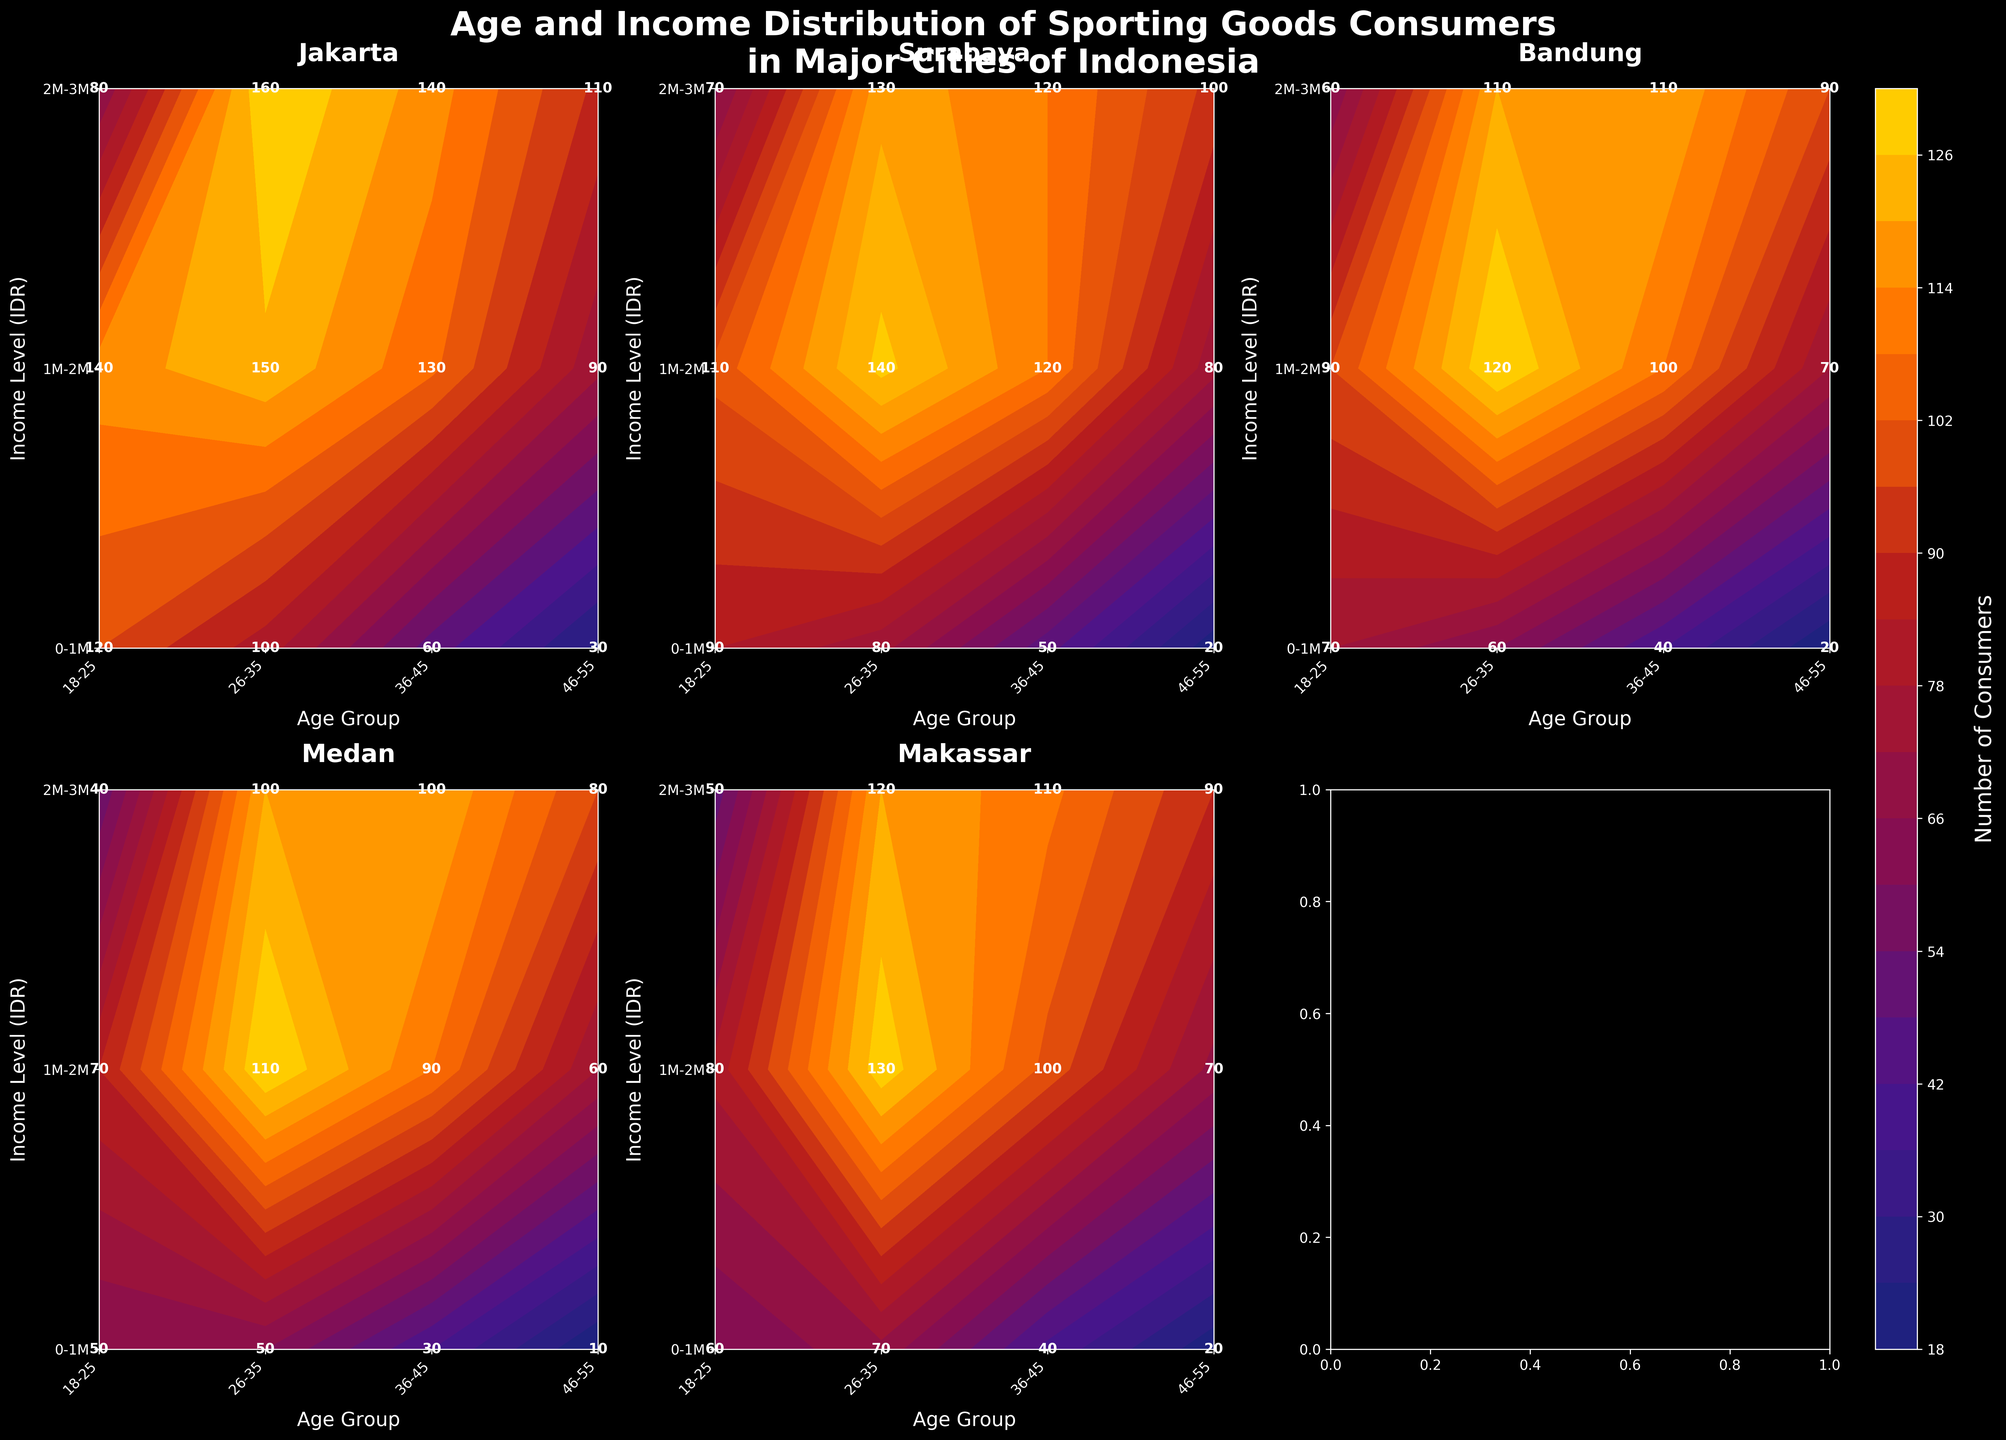What is the title of the figure? The title is typically displayed at the top of the figure. In this case, it reads: "Age and Income Distribution of Sporting Goods Consumers in Major Cities of Indonesia".
Answer: Age and Income Distribution of Sporting Goods Consumers in Major Cities of Indonesia How many cities are represented in the figure? The figure uses subplots to show different major cities in Indonesia. By counting the title headers for each subplot, we identify five cities.
Answer: Five Which city shows the highest number of consumers in the '18-25' age group with an income level of '1M-2M'? By examining the annotations within the contour plot under each city's subplot, we find that Jakarta shows the highest number of consumers, with 140.
Answer: Jakarta Which income level has the highest number of consumers in the '26-35' age group in Surabaya? By checking the contour plot's annotations for Surabaya in the '26-35' age group, we see that the '1M-2M' income level has the highest number of consumers with 140.
Answer: 1M-2M What city has the least number of consumers in the 46-55 age group earning between 0-1M? By looking at the values in the contour plots for different cities, we deduce that Medan has the least number of consumers in this category with 10 consumers.
Answer: Medan Compare the number of consumers in the '36-45' age group with an income level of '2M-3M' between Jakarta and Makassar. Which city has more consumers? By comparing the respective annotation values, Jakarta shows 140 consumers while Makassar shows 110 consumers in this category. Hence, Jakarta has more consumers.
Answer: Jakarta Which age group has the highest number of consumers in Medan, regardless of income level? We need to sum the number of consumers across all income levels within each age group in Medan. The sums are: 18-25 (50+70+40)=160, 26-35 (50+110+100)=260, 36-45 (30+90+100)=220, and 46-55 (10+60+80)=150. The '26-35' age group predominates.
Answer: 26-35 Across all cities, which age group and income level combination appears most frequently in terms of the highest number of consumers within each subplot? By scanning through each subplot's annotations for the highest numbers, we predominantly see high numbers for the '26-35' age group with the '2M-3M' income level. This combination contains the highest in Jakarta (160), Surabaya (130), Bandung (110), Medan (100), Makassar (120).
Answer: 26-35 and 2M-3M What is the overall trend observed in the distribution of consumers by age and income level in Jakarta? Observing Jakarta's subplot, the general trend is that higher-income levels tend to have more consumers as the age group increases, peaking in the '26-35' age group with the '2M-3M' income level.
Answer: Higher income levels have more consumers in older age groups 